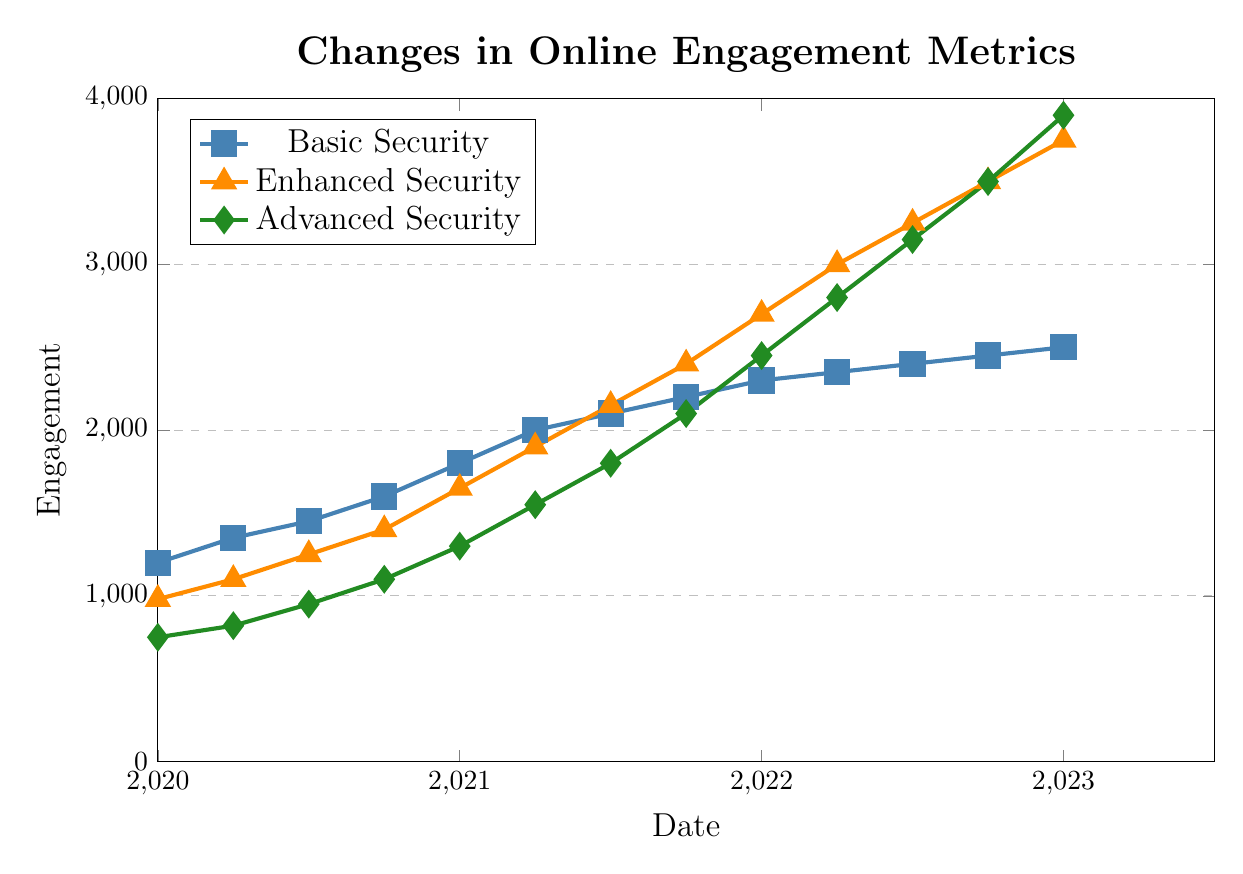What security level had the highest online engagement in 2021? To answer this, observe the data points for the year 2021 and compare the engagement metrics for Basic, Enhanced, and Advanced Security. In 2021, the engagement metrics for Basic Security ranged from 1800 to 2200, for Enhanced Security from 1650 to 2400, and for Advanced Security from 1300 to 2100. Enhanced Security had the highest metric at 2400 in 2021.
Answer: Enhanced Security By how much did the engagement for Advanced Security increase from 2020 to 2023? Subtract the engagement value of Advanced Security in 2020 from that in 2023. In 2020, the engagement was 750, and in 2023, it was 3900. The increase is 3900 - 750 = 3150.
Answer: 3150 Which category saw the greatest increase in engagement from the start of 2020 to the end of 2022? Calculate the engagement increase for each category from 2020 to the end of 2022. Basic Security increased from 1200 to 2450 (an increase of 1250), Enhanced Security increased from 980 to 3500 (an increase of 2520), and Advanced Security increased from 750 to 3500 (an increase of 3150). Advanced Security saw the greatest increase with 3150.
Answer: Advanced Security What was the average engagement for Enhanced Security in 2022? Identify the engagement values for Enhanced Security in 2022 and compute their average. The values are 2700 (Jan), 3000 (Apr), 3250 (Jul), and 3500 (Oct). The average is (2700 + 3000 + 3250 + 3500) / 4 = 3112.5.
Answer: 3112.5 By how much did engagement for Basic Security differ between the start of 2021 and the end of 2022? Identify the engagement at the start of 2021 and the end of 2022 for Basic Security. The values are 1800 (2021) and 2450 (end of 2022). The difference is 2450 - 1800 = 650.
Answer: 650 What is the engagement trend for each security level over the three years depicted? Observe the slopes of the lines representing each security level. Basic Security increases steadily from 1200 to 2500, Enhanced Security increases continuously and steeply from 980 to 3750, and Advanced Security shows the most significant increase from 750 to 3900. All security levels demonstrate an increasing trend over the years.
Answer: Increasing Which month of 2022 shows the highest engagement for Advanced Security? Check the engagement values for Advanced Security in 2022 for each month: Jan (2450), Apr (2800), Jul (3150), Oct (3500). October displays the highest engagement at 3500.
Answer: October How does the engagement for Enhanced Security in July 2021 compare to that for Basic Security in the same period? Compare the engagement values for Enhanced Security (2150) and Basic Security (2100) in July 2021. Enhanced Security has a higher engagement by 50.
Answer: Enhanced Security is 50 higher By how much did the engagement for Basic Security increase each quarter in 2020? Calculate the quarterly increase for Basic Security in 2020: Jan (1200), Apr (1350), Jul (1450), and Oct (1600). Q1 to Q2: 1350 - 1200 = 150; Q2 to Q3: 1450 - 1350 = 100; Q3 to Q4: 1600 - 1450 = 150. The quarterly increases in 2020 are 150, 100, and 150.
Answer: 150, 100, 150 What is the difference in engagement between Basic Security and Advanced Security at the end of 2021? Compare the engagement values of Basic Security (2200) and Advanced Security (2100) at the end of 2021. The difference is 2200 - 2100 = 100.
Answer: 100 